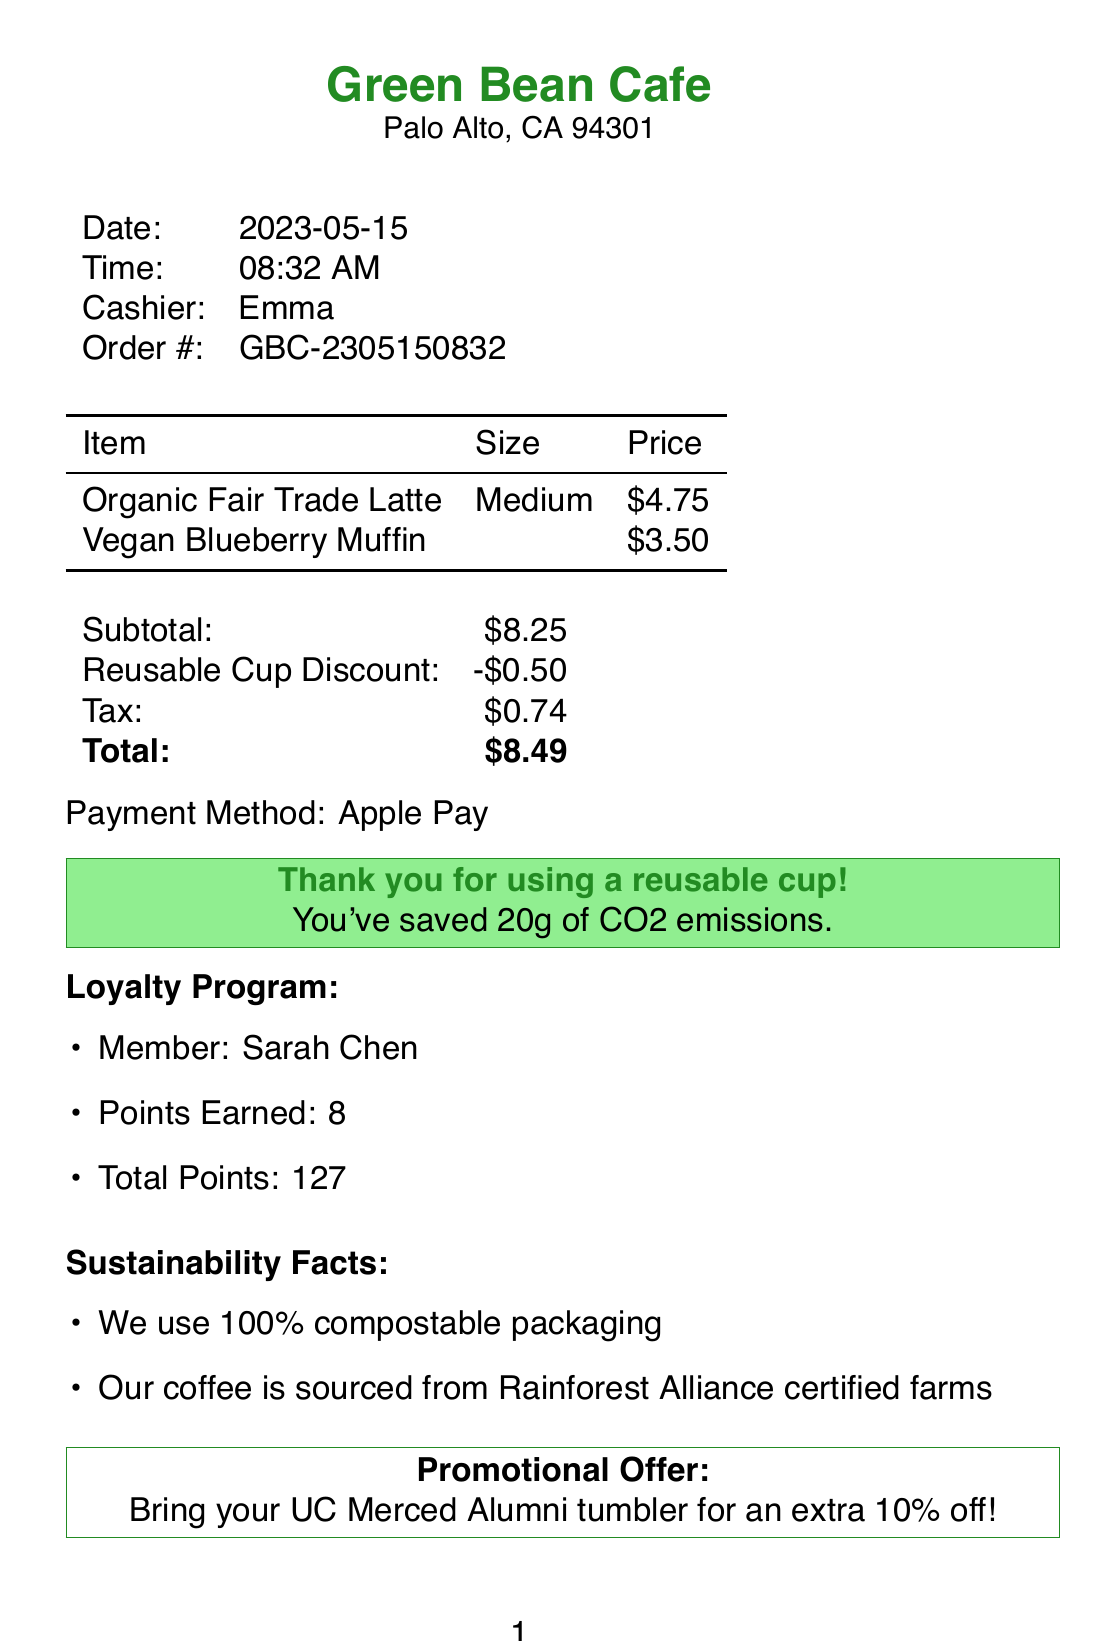What is the name of the coffee shop? The name of the coffee shop is located at the top of the receipt.
Answer: Green Bean Cafe What was the total amount charged? The total amount charged is shown at the end of the itemized costs on the receipt.
Answer: $8.49 Who was the cashier? The cashier's name is listed in the document.
Answer: Emma What date was the purchase made? The purchase date is prominently displayed in the document.
Answer: 2023-05-15 How much is the reusable cup discount? The reusable cup discount is specified in the cost summary.
Answer: -$0.50 How many loyalty points were earned? The points earned from the loyalty program are explicitly mentioned.
Answer: 8 What is the eco-friendly message given? The eco-friendly message details the environmental impact of using a reusable cup.
Answer: Thank you for using a reusable cup! You've saved 20g of CO2 emissions What promotional offer is mentioned? The promotional offer is highlighted separately in the document.
Answer: Bring your UC Merced Alumni tumbler for an extra 10% off! What are two sustainability facts provided? The sustainability facts are listed under a specific section in the document.
Answer: We use 100% compostable packaging and Our coffee is sourced from Rainforest Alliance certified farms 